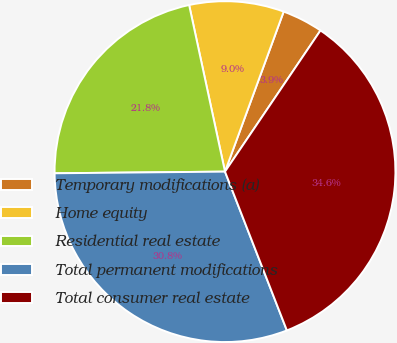Convert chart to OTSL. <chart><loc_0><loc_0><loc_500><loc_500><pie_chart><fcel>Temporary modifications (a)<fcel>Home equity<fcel>Residential real estate<fcel>Total permanent modifications<fcel>Total consumer real estate<nl><fcel>3.87%<fcel>8.97%<fcel>21.78%<fcel>30.76%<fcel>34.62%<nl></chart> 